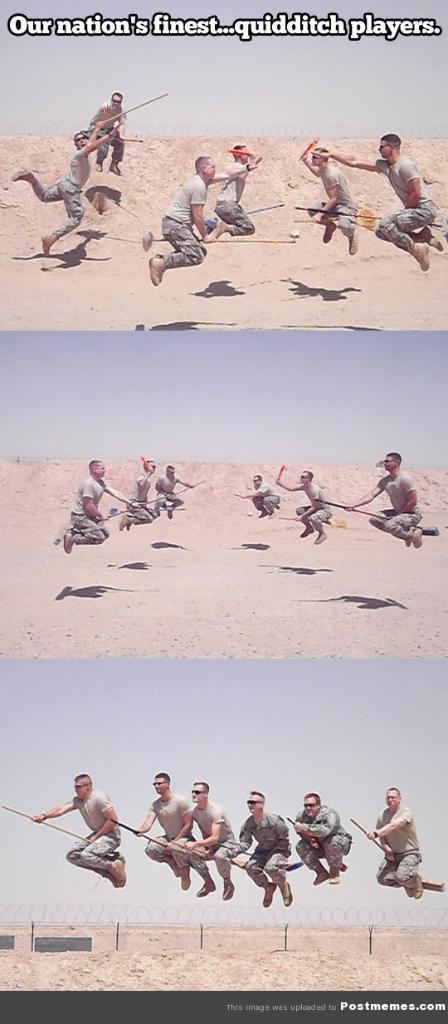<image>
Share a concise interpretation of the image provided. groups of men flying on brooms outdoors playing a game of quidditch 